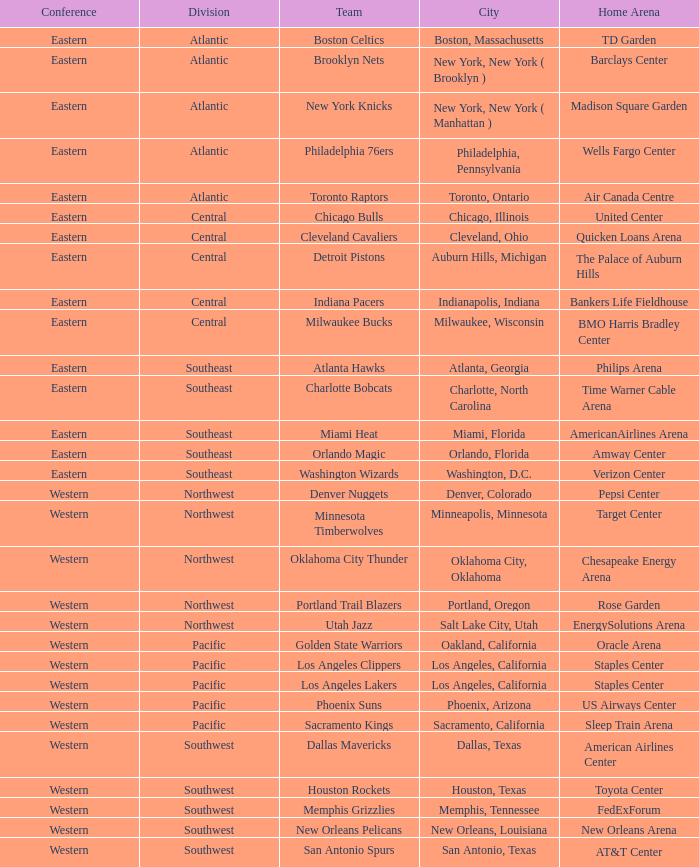Which team is in the Southeast with a home at Philips Arena? Atlanta Hawks. 